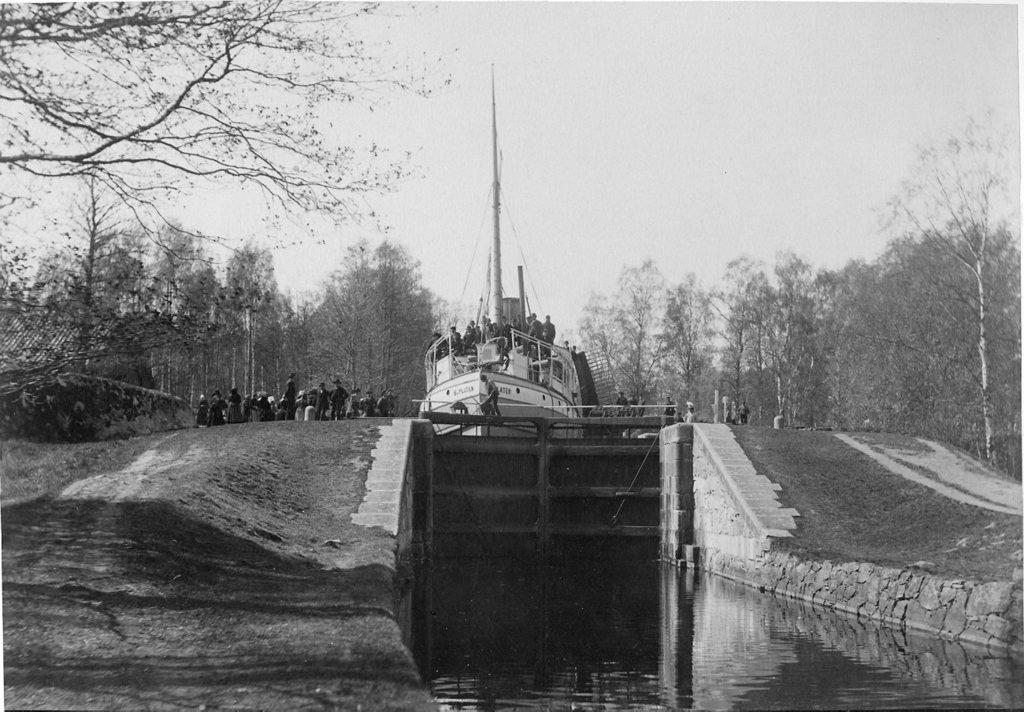Can you describe this image briefly? This is a black and white picture. I can see group of people standing on the ship. I can see a gate in the water, and in the background there are trees and the sky. 